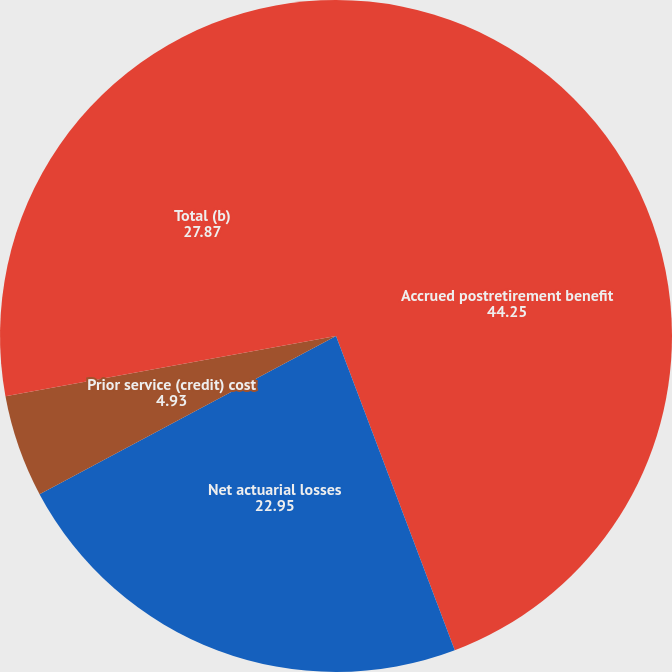<chart> <loc_0><loc_0><loc_500><loc_500><pie_chart><fcel>Accrued postretirement benefit<fcel>Net actuarial losses<fcel>Prior service (credit) cost<fcel>Total (b)<nl><fcel>44.25%<fcel>22.95%<fcel>4.93%<fcel>27.87%<nl></chart> 